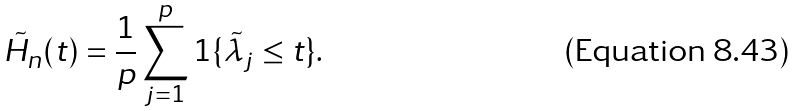Convert formula to latex. <formula><loc_0><loc_0><loc_500><loc_500>\tilde { H } _ { n } ( t ) = \frac { 1 } { p } \sum _ { j = 1 } ^ { p } 1 \{ \tilde { \lambda } _ { j } \leq t \} .</formula> 